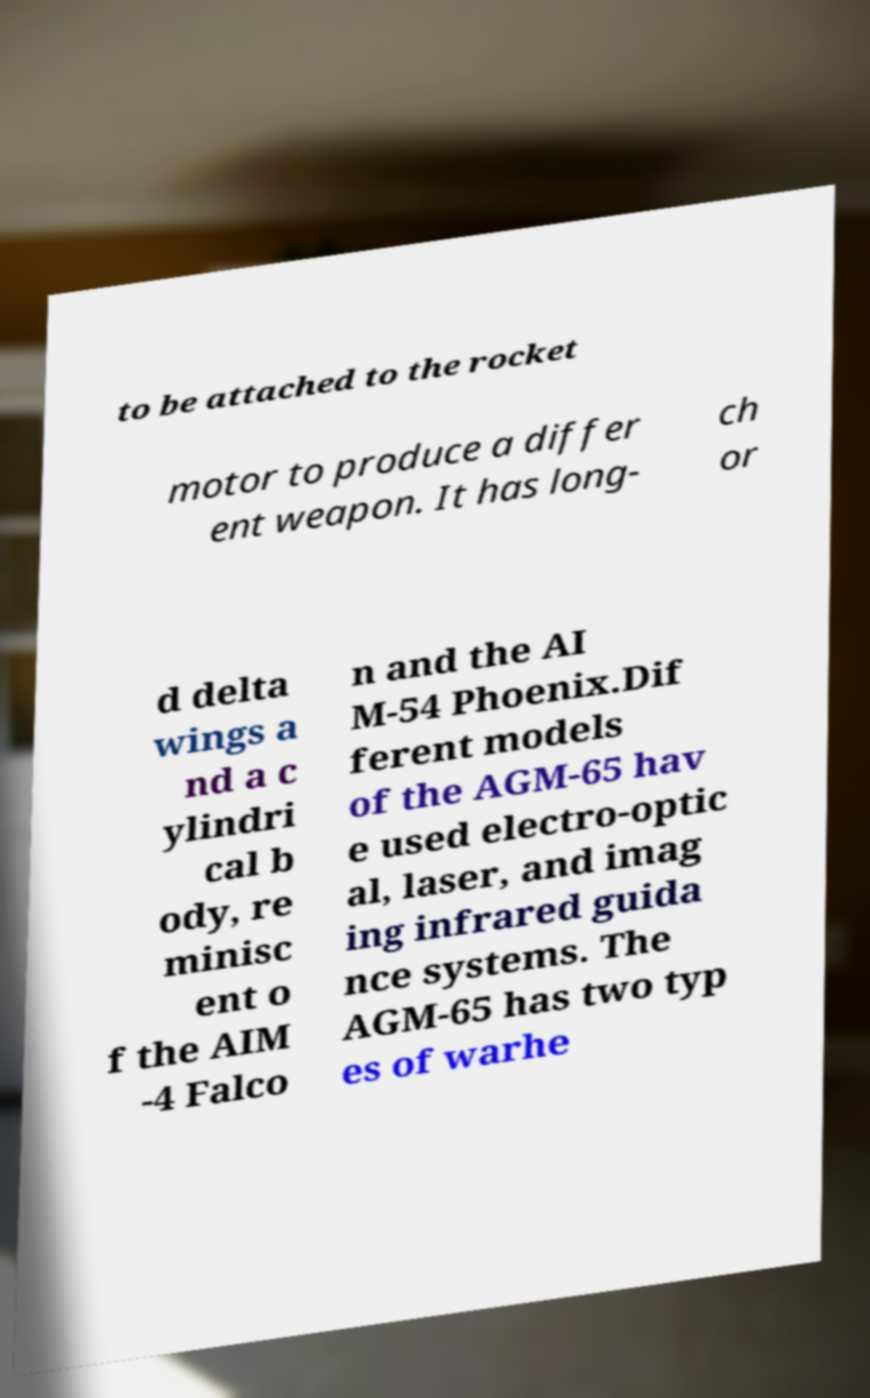What messages or text are displayed in this image? I need them in a readable, typed format. to be attached to the rocket motor to produce a differ ent weapon. It has long- ch or d delta wings a nd a c ylindri cal b ody, re minisc ent o f the AIM -4 Falco n and the AI M-54 Phoenix.Dif ferent models of the AGM-65 hav e used electro-optic al, laser, and imag ing infrared guida nce systems. The AGM-65 has two typ es of warhe 